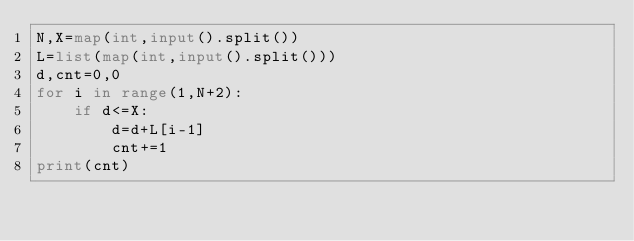<code> <loc_0><loc_0><loc_500><loc_500><_Python_>N,X=map(int,input().split())
L=list(map(int,input().split()))
d,cnt=0,0
for i in range(1,N+2):
    if d<=X:
        d=d+L[i-1]
        cnt+=1
print(cnt)
</code> 